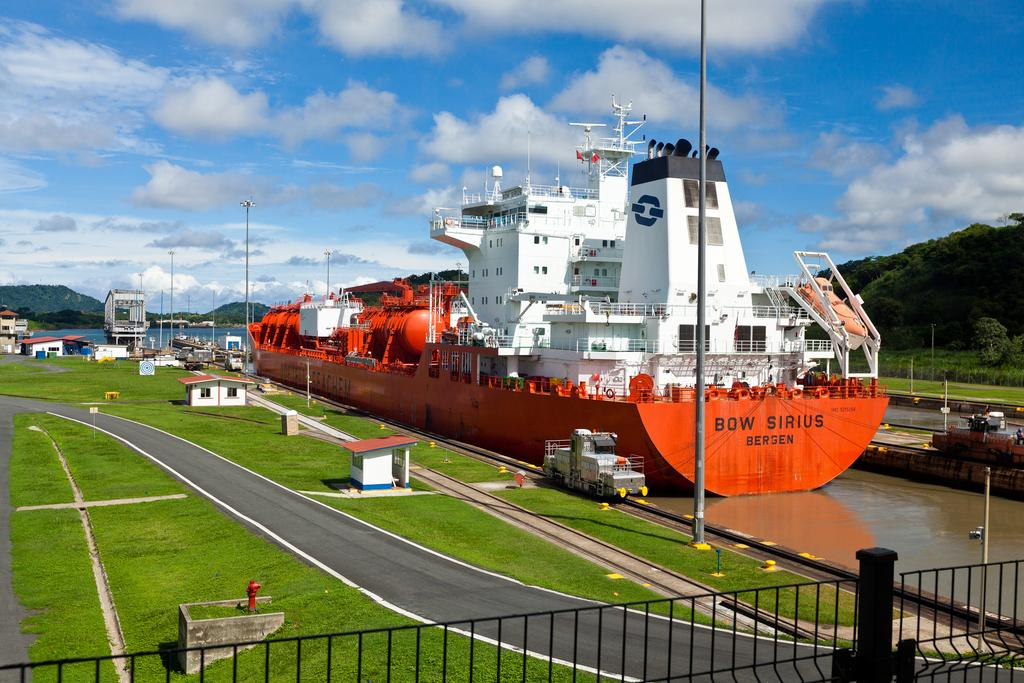What is the main subject of the image? The main subject of the image is a ship. What other watercraft can be seen in the image? There are boats in the image. What is the primary setting of the image? The image features water, poles, a fence, grass, a road, trees, and hills in the background. What is visible in the background of the image? There are hills and sky visible in the background of the image. Can you describe the other objects present in the image? There are other objects in the image, but their specific details are not mentioned in the provided facts. What advice does the maid give to the sorting machine in the image? There is no maid or sorting machine present in the image. 